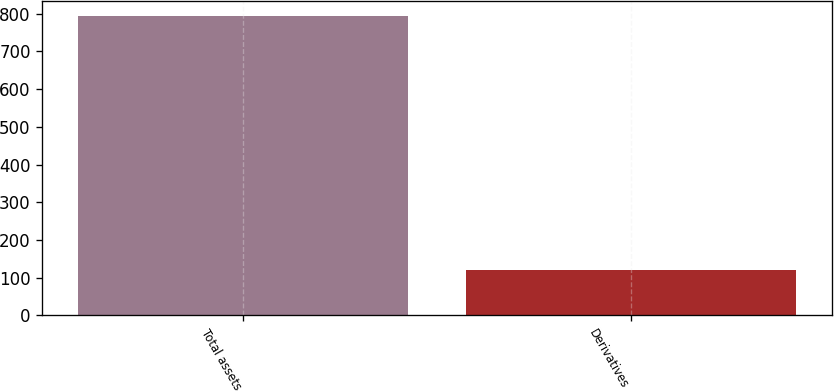<chart> <loc_0><loc_0><loc_500><loc_500><bar_chart><fcel>Total assets<fcel>Derivatives<nl><fcel>793<fcel>120<nl></chart> 